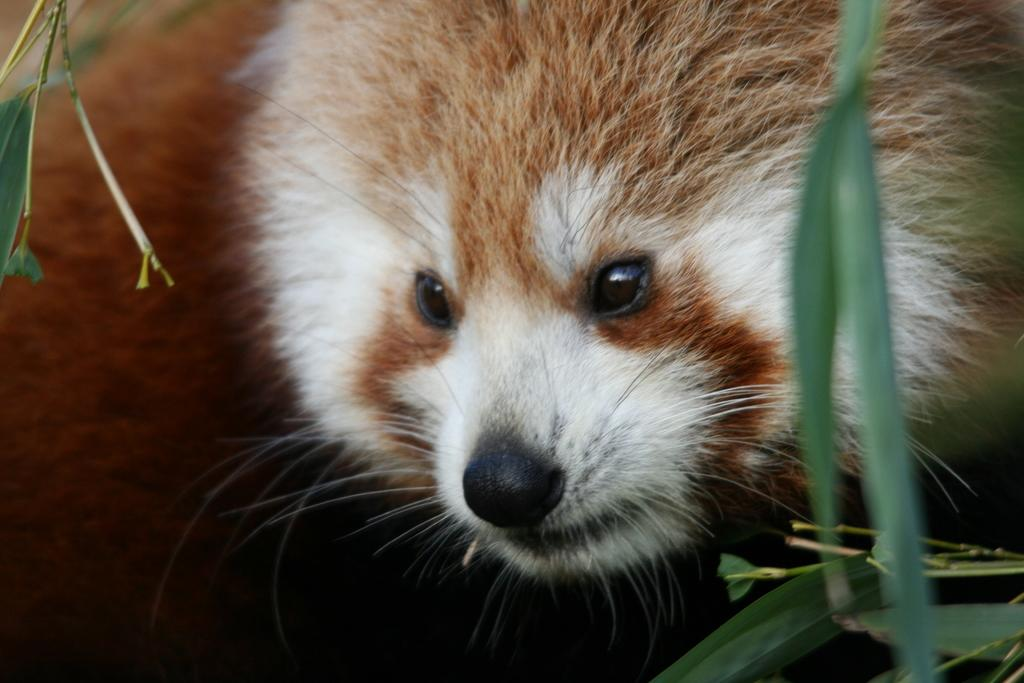What is the main subject in the center of the image? There is an animal in the center of the image. What type of vegetation can be seen on the right side of the image? There is grass on the right side of the image. What type of test is being conducted on the animal's lip in the image? There is no test or lip present in the image; it only features an animal and grass. 